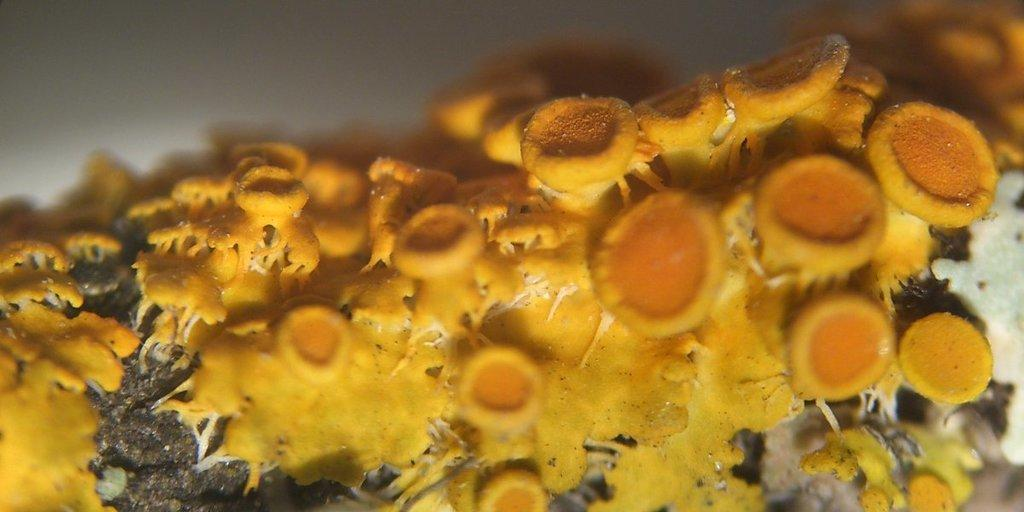What type of fungi can be seen in the image? There are yellow mushrooms in the image. What type of treatment is being administered to the ducks in the image? There are no ducks present in the image, so no treatment can be observed. What type of engine is visible in the image? There is no engine present in the image; it features yellow mushrooms. 